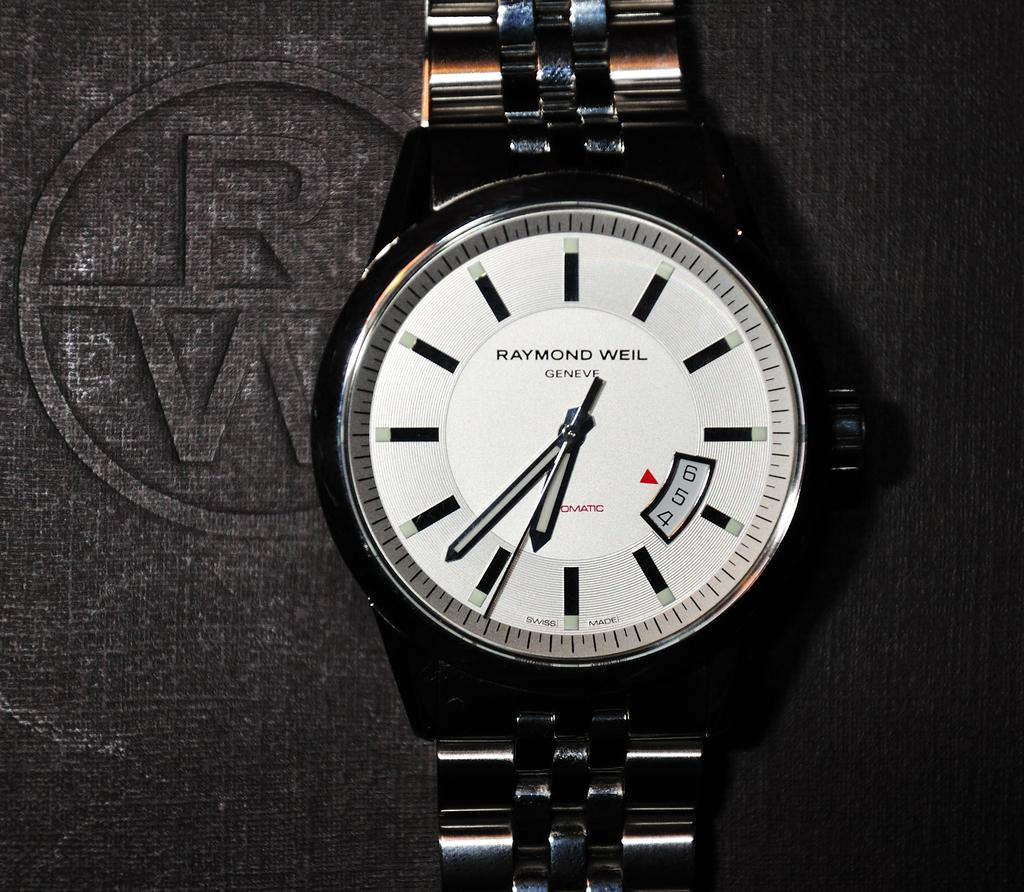<image>
Share a concise interpretation of the image provided. A Raymond Weil watch shows the luxury of man 